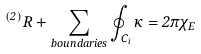<formula> <loc_0><loc_0><loc_500><loc_500>^ { ( 2 ) } R + \sum _ { b o u n d a r i e s } \oint _ { C _ { i } } \kappa = 2 \pi \chi _ { E }</formula> 